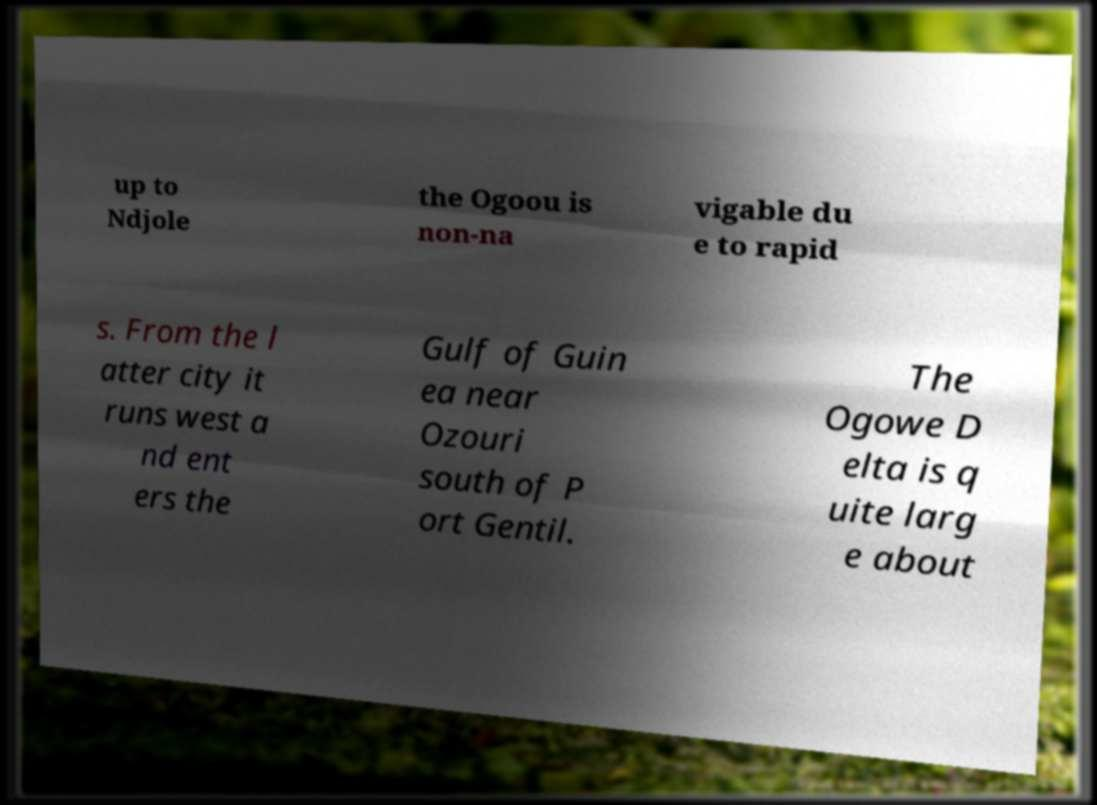There's text embedded in this image that I need extracted. Can you transcribe it verbatim? up to Ndjole the Ogoou is non-na vigable du e to rapid s. From the l atter city it runs west a nd ent ers the Gulf of Guin ea near Ozouri south of P ort Gentil. The Ogowe D elta is q uite larg e about 